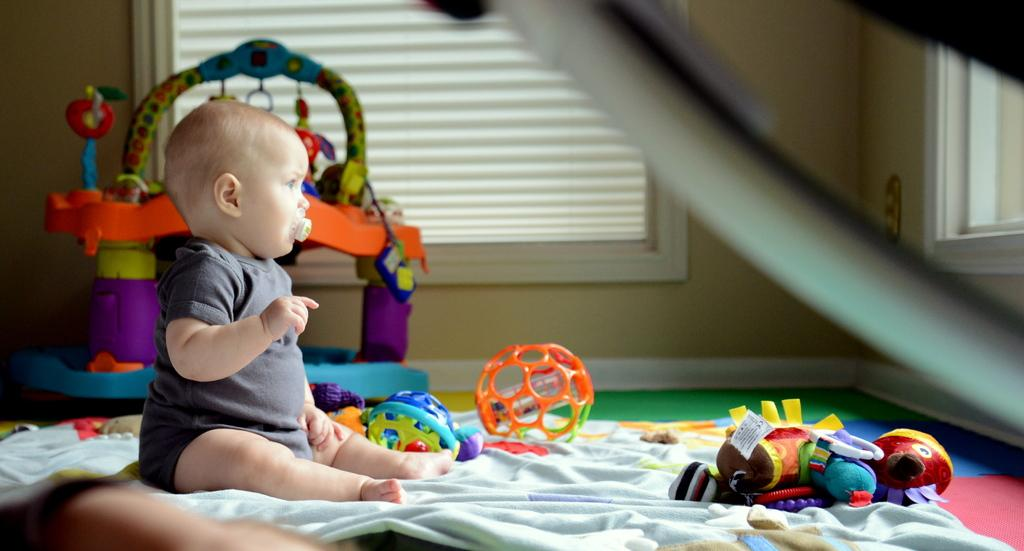What is the main subject of the image? There is a kid sitting in the image. What else can be seen in the image besides the kid? There are toys in the image, including a toy at the back. What is visible in the background of the image? There are windows in the image. What type of surface is visible in the image? There is a floor visible in the image. What type of cork can be seen in the image? There is no cork present in the image. Is the pig mentioned in the image? No, there is no mention of a pig in the image. 